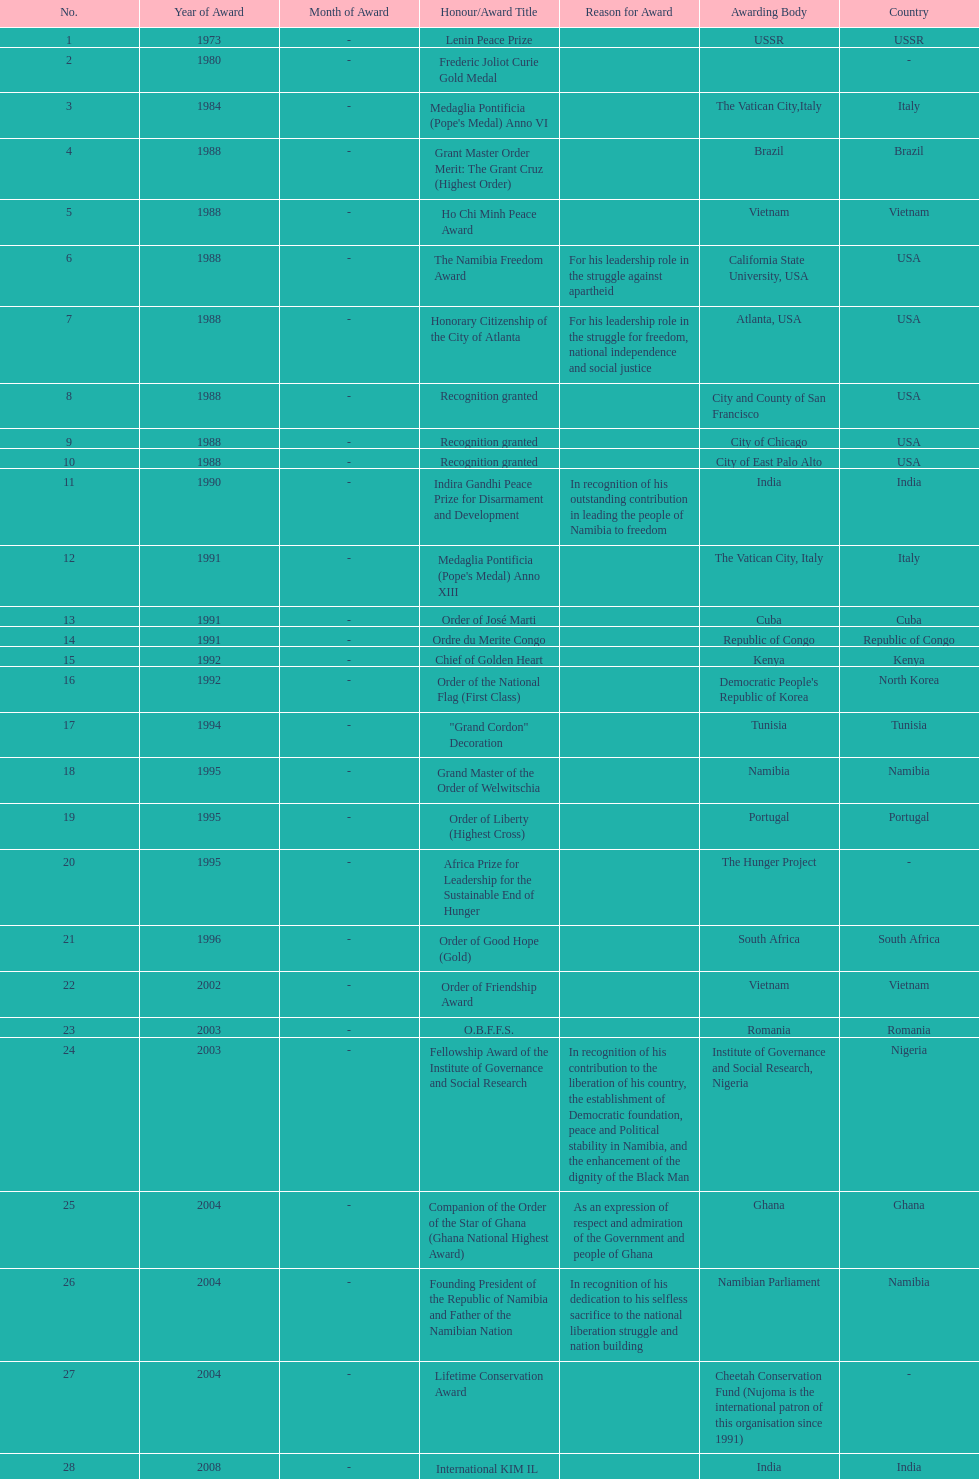What was the name of the honor/award title given after the international kim il sung prize certificate? Sir Seretse Khama SADC Meda. 